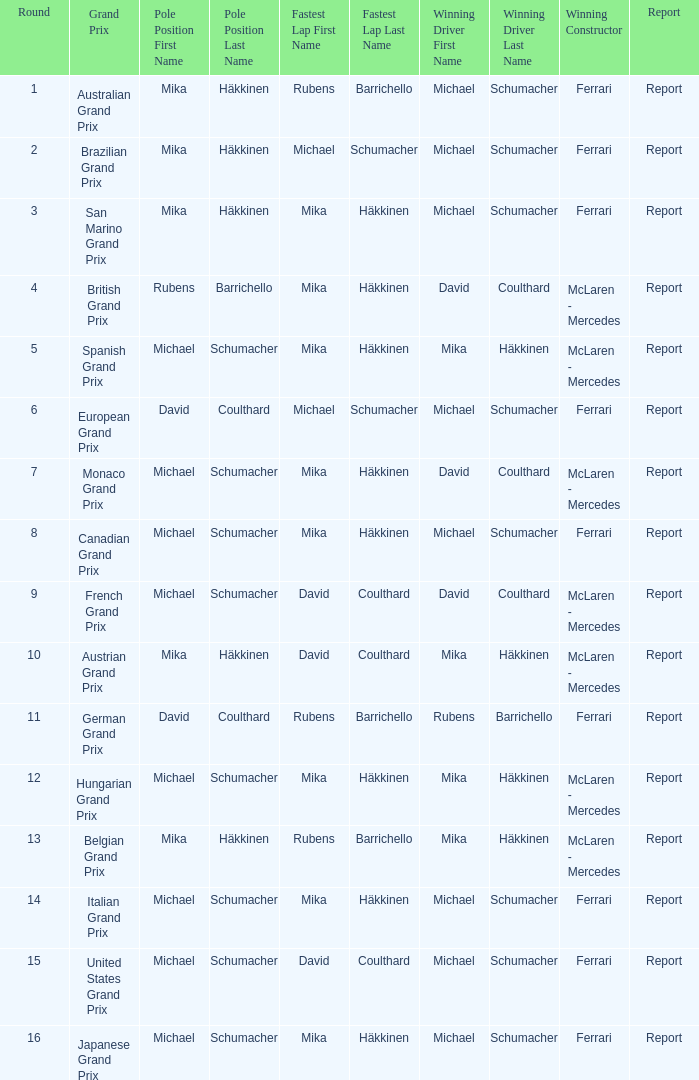Which round had Michael Schumacher in the pole position, David Coulthard with the fastest lap, and McLaren - Mercedes as the winning constructor? 1.0. Could you help me parse every detail presented in this table? {'header': ['Round', 'Grand Prix', 'Pole Position First Name', 'Pole Position Last Name', 'Fastest Lap First Name', 'Fastest Lap Last Name', 'Winning Driver First Name', 'Winning Driver Last Name', 'Winning Constructor', 'Report'], 'rows': [['1', 'Australian Grand Prix', 'Mika', 'Häkkinen', 'Rubens', 'Barrichello', 'Michael', 'Schumacher', 'Ferrari', 'Report'], ['2', 'Brazilian Grand Prix', 'Mika', 'Häkkinen', 'Michael', 'Schumacher', 'Michael', 'Schumacher', 'Ferrari', 'Report'], ['3', 'San Marino Grand Prix', 'Mika', 'Häkkinen', 'Mika', 'Häkkinen', 'Michael', 'Schumacher', 'Ferrari', 'Report'], ['4', 'British Grand Prix', 'Rubens', 'Barrichello', 'Mika', 'Häkkinen', 'David', 'Coulthard', 'McLaren - Mercedes', 'Report'], ['5', 'Spanish Grand Prix', 'Michael', 'Schumacher', 'Mika', 'Häkkinen', 'Mika', 'Häkkinen', 'McLaren - Mercedes', 'Report'], ['6', 'European Grand Prix', 'David', 'Coulthard', 'Michael', 'Schumacher', 'Michael', 'Schumacher', 'Ferrari', 'Report'], ['7', 'Monaco Grand Prix', 'Michael', 'Schumacher', 'Mika', 'Häkkinen', 'David', 'Coulthard', 'McLaren - Mercedes', 'Report'], ['8', 'Canadian Grand Prix', 'Michael', 'Schumacher', 'Mika', 'Häkkinen', 'Michael', 'Schumacher', 'Ferrari', 'Report'], ['9', 'French Grand Prix', 'Michael', 'Schumacher', 'David', 'Coulthard', 'David', 'Coulthard', 'McLaren - Mercedes', 'Report'], ['10', 'Austrian Grand Prix', 'Mika', 'Häkkinen', 'David', 'Coulthard', 'Mika', 'Häkkinen', 'McLaren - Mercedes', 'Report'], ['11', 'German Grand Prix', 'David', 'Coulthard', 'Rubens', 'Barrichello', 'Rubens', 'Barrichello', 'Ferrari', 'Report'], ['12', 'Hungarian Grand Prix', 'Michael', 'Schumacher', 'Mika', 'Häkkinen', 'Mika', 'Häkkinen', 'McLaren - Mercedes', 'Report'], ['13', 'Belgian Grand Prix', 'Mika', 'Häkkinen', 'Rubens', 'Barrichello', 'Mika', 'Häkkinen', 'McLaren - Mercedes', 'Report'], ['14', 'Italian Grand Prix', 'Michael', 'Schumacher', 'Mika', 'Häkkinen', 'Michael', 'Schumacher', 'Ferrari', 'Report'], ['15', 'United States Grand Prix', 'Michael', 'Schumacher', 'David', 'Coulthard', 'Michael', 'Schumacher', 'Ferrari', 'Report'], ['16', 'Japanese Grand Prix', 'Michael', 'Schumacher', 'Mika', 'Häkkinen', 'Michael', 'Schumacher', 'Ferrari', 'Report']]} 